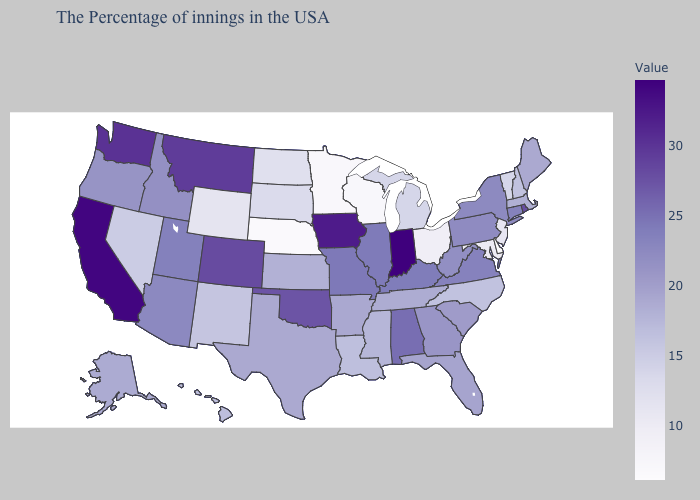Does Arizona have a lower value than Oklahoma?
Give a very brief answer. Yes. Which states have the lowest value in the USA?
Be succinct. Delaware. Does the map have missing data?
Short answer required. No. Does Vermont have the lowest value in the USA?
Answer briefly. No. Among the states that border Wyoming , which have the highest value?
Short answer required. Montana. Does Texas have a higher value than Montana?
Quick response, please. No. 